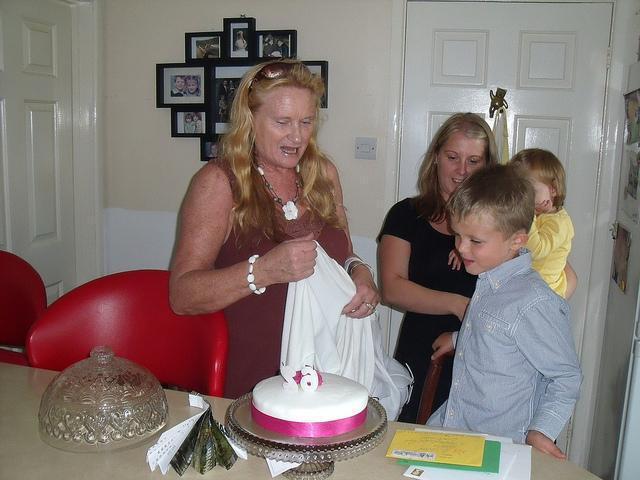How many people are visible?
Give a very brief answer. 4. How many chairs are there?
Give a very brief answer. 2. How many cats are shown?
Give a very brief answer. 0. 